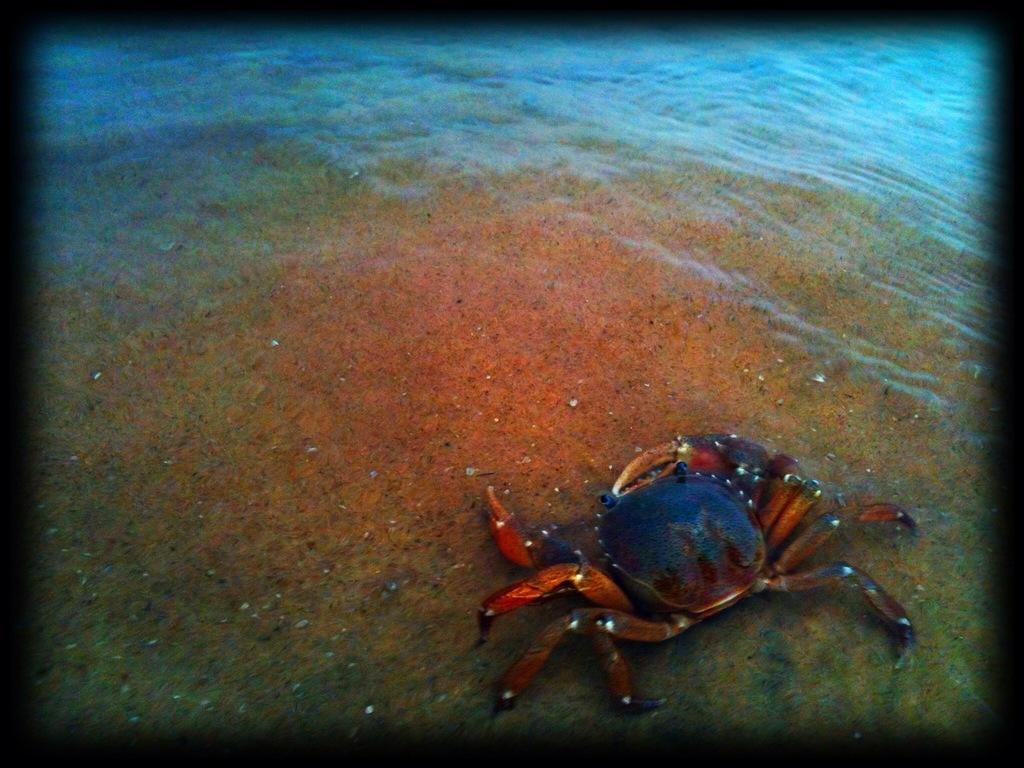Can you describe this image briefly? In this image we can see there is a crab in the water. 